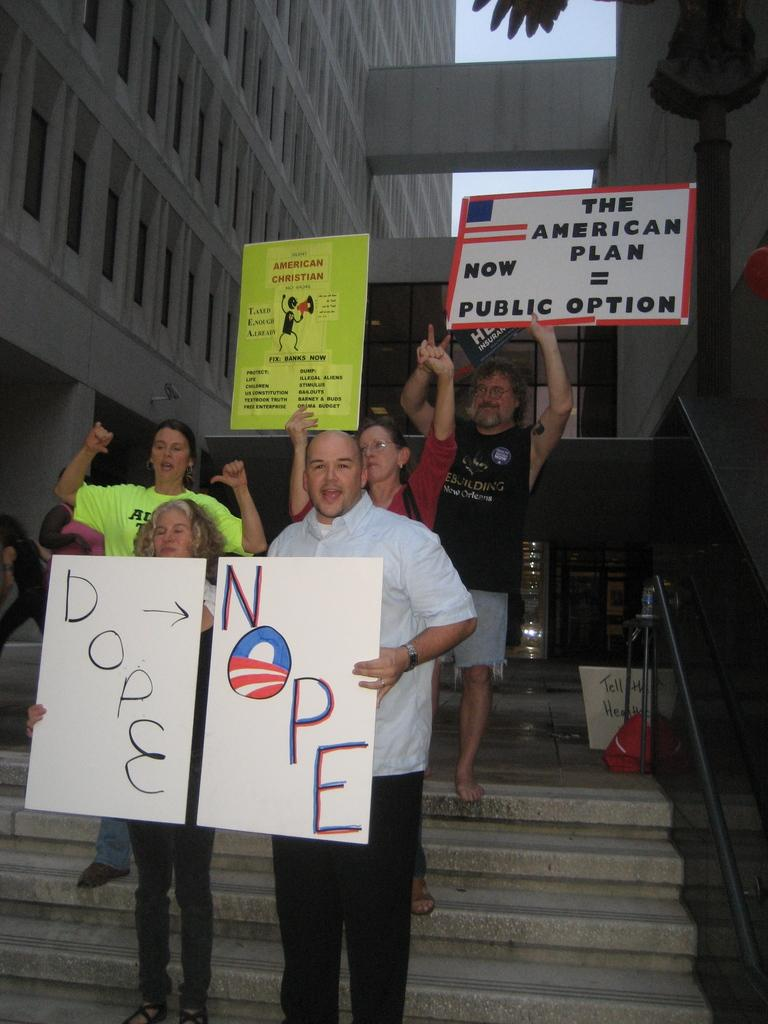How many people are in the image? There is a group of people in the image, but the exact number is not specified. What are some people doing in the image? Some people are holding placards in the image. What objects can be seen in the image besides the people and placards? There are metal rods visible in the image. What can be seen in the background of the image? There are buildings and a pole in the background of the image. What type of bear can be seen holding a piece of coal in the image? There is no bear or coal present in the image. 